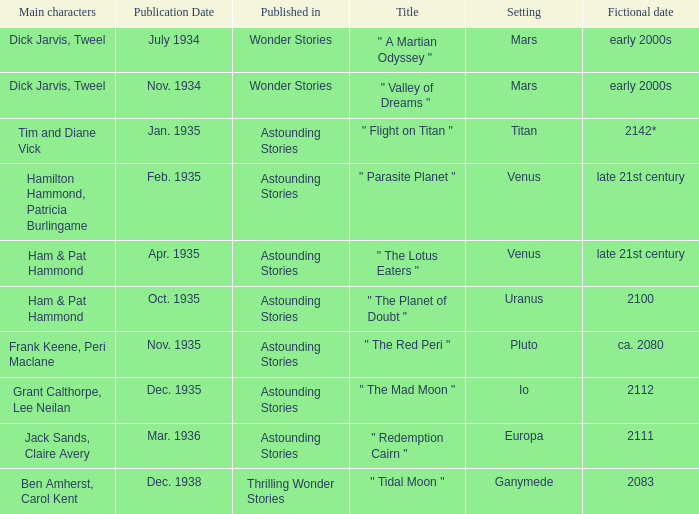Name the publication date when the fictional date is 2112 Dec. 1935. 